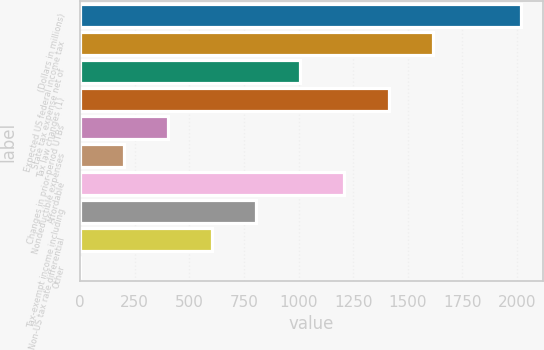<chart> <loc_0><loc_0><loc_500><loc_500><bar_chart><fcel>(Dollars in millions)<fcel>Expected US federal income tax<fcel>State tax expense net of<fcel>Tax law changes (1)<fcel>Changes in prior-period UTBs<fcel>Nondeductible expenses<fcel>Affordable<fcel>Tax-exempt income including<fcel>Non-US tax rate differential<fcel>Other<nl><fcel>2017<fcel>1613.64<fcel>1008.6<fcel>1411.96<fcel>403.56<fcel>201.88<fcel>1210.28<fcel>806.92<fcel>605.24<fcel>0.2<nl></chart> 